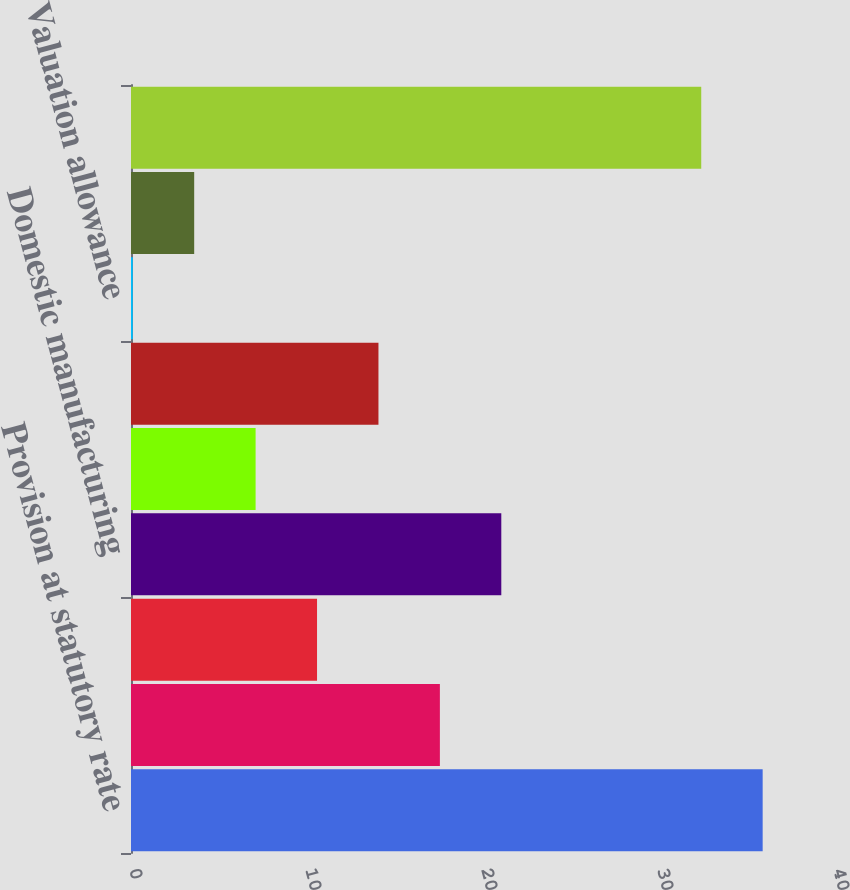Convert chart to OTSL. <chart><loc_0><loc_0><loc_500><loc_500><bar_chart><fcel>Provision at statutory rate<fcel>State taxes net of federal<fcel>Foreign rate differential<fcel>Domestic manufacturing<fcel>Research and development<fcel>Unrecognized tax benefits<fcel>Valuation allowance<fcel>Adjustments for previously<fcel>Provision for income taxes<nl><fcel>35.89<fcel>17.55<fcel>10.57<fcel>21.04<fcel>7.08<fcel>14.06<fcel>0.1<fcel>3.59<fcel>32.4<nl></chart> 